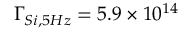<formula> <loc_0><loc_0><loc_500><loc_500>\Gamma _ { S i , 5 H z } = 5 . 9 \times 1 0 ^ { 1 4 }</formula> 